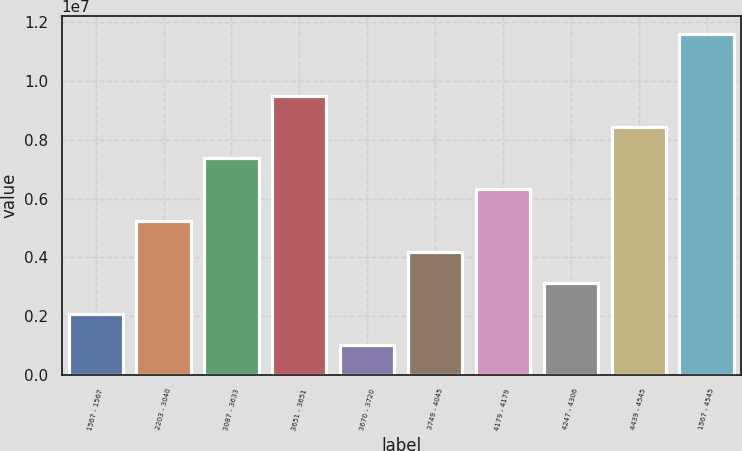Convert chart. <chart><loc_0><loc_0><loc_500><loc_500><bar_chart><fcel>1567 - 1567<fcel>2203 - 3040<fcel>3087 - 3633<fcel>3651 - 3651<fcel>3670 - 3720<fcel>3749 - 4045<fcel>4179 - 4179<fcel>4247 - 4306<fcel>4439 - 4545<fcel>1567 - 4545<nl><fcel>2.0673e+06<fcel>5.25166e+06<fcel>7.37457e+06<fcel>9.49748e+06<fcel>1.00584e+06<fcel>4.19021e+06<fcel>6.31312e+06<fcel>3.12875e+06<fcel>8.43603e+06<fcel>1.16204e+07<nl></chart> 